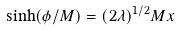Convert formula to latex. <formula><loc_0><loc_0><loc_500><loc_500>\sinh ( \phi / M ) = ( 2 \lambda ) ^ { 1 / 2 } M x</formula> 